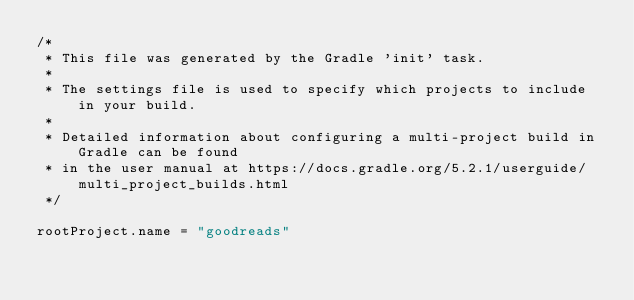Convert code to text. <code><loc_0><loc_0><loc_500><loc_500><_Kotlin_>/*
 * This file was generated by the Gradle 'init' task.
 *
 * The settings file is used to specify which projects to include in your build.
 *
 * Detailed information about configuring a multi-project build in Gradle can be found
 * in the user manual at https://docs.gradle.org/5.2.1/userguide/multi_project_builds.html
 */

rootProject.name = "goodreads"
</code> 